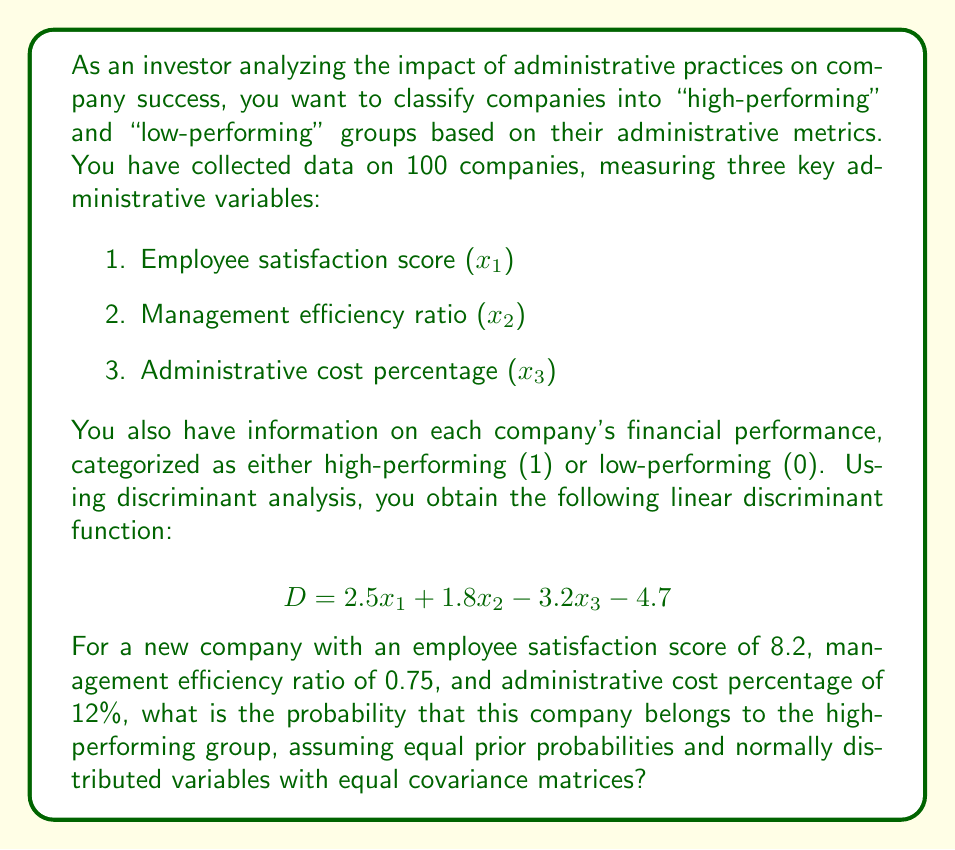Help me with this question. To solve this problem, we'll follow these steps:

1. Calculate the discriminant score (D) for the new company.
2. Determine the cutoff point between the two groups.
3. Calculate the z-score based on the discriminant score.
4. Use the standard normal distribution to find the probability.

Step 1: Calculate the discriminant score (D)
Using the given linear discriminant function and the new company's data:

$$ D = 2.5x_1 + 1.8x_2 - 3.2x_3 - 4.7 $$
$$ D = 2.5(8.2) + 1.8(0.75) - 3.2(12) - 4.7 $$
$$ D = 20.5 + 1.35 - 38.4 - 4.7 $$
$$ D = -21.25 $$

Step 2: Determine the cutoff point
With equal prior probabilities, the cutoff point is 0.

Step 3: Calculate the z-score
To calculate the z-score, we need the mean and standard deviation of the discriminant scores. Since this information is not provided, we'll use a common approach of estimating these values based on the discriminant function coefficients.

Estimated mean difference between groups:
$$ \mu_D = \frac{1}{2}\sum_{i=1}^{3} |a_i| = \frac{1}{2}(|2.5| + |1.8| + |-3.2|) = 3.75 $$

Estimated pooled standard deviation:
$$ \sigma_D = \frac{1}{2}\sqrt{\sum_{i=1}^{3} a_i^2} = \frac{1}{2}\sqrt{2.5^2 + 1.8^2 + (-3.2)^2} = 2.18 $$

Z-score:
$$ z = \frac{D - 0}{\sigma_D} = \frac{-21.25 - 0}{2.18} = -9.75 $$

Step 4: Calculate the probability
Using the standard normal distribution, we can find the probability that the company belongs to the high-performing group:

$$ P(D > 0 | D = -21.25) = 1 - \Phi(z) $$

Where Φ(z) is the cumulative distribution function of the standard normal distribution.

$$ P(D > 0 | D = -21.25) = 1 - \Phi(-9.75) $$

Using a standard normal distribution table or calculator, we find:

$$ \Phi(-9.75) \approx 0 $$

Therefore, the probability is:

$$ P(D > 0 | D = -21.25) = 1 - 0 = 1 $$
Answer: The probability that the new company belongs to the high-performing group is approximately 0. 